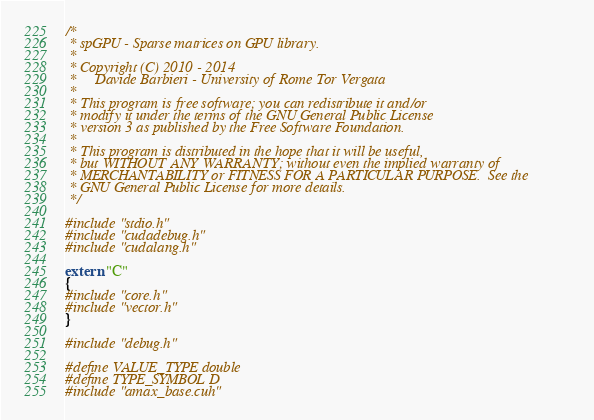<code> <loc_0><loc_0><loc_500><loc_500><_Cuda_>/*
 * spGPU - Sparse matrices on GPU library.
 * 
 * Copyright (C) 2010 - 2014
 *     Davide Barbieri - University of Rome Tor Vergata
 *
 * This program is free software; you can redistribute it and/or
 * modify it under the terms of the GNU General Public License
 * version 3 as published by the Free Software Foundation.
 *
 * This program is distributed in the hope that it will be useful,
 * but WITHOUT ANY WARRANTY; without even the implied warranty of
 * MERCHANTABILITY or FITNESS FOR A PARTICULAR PURPOSE.  See the
 * GNU General Public License for more details.
 */
 
#include "stdio.h"
#include "cudadebug.h"
#include "cudalang.h"

extern "C"
{
#include "core.h"
#include "vector.h"
}

#include "debug.h"

#define VALUE_TYPE double
#define TYPE_SYMBOL D
#include "amax_base.cuh"

</code> 